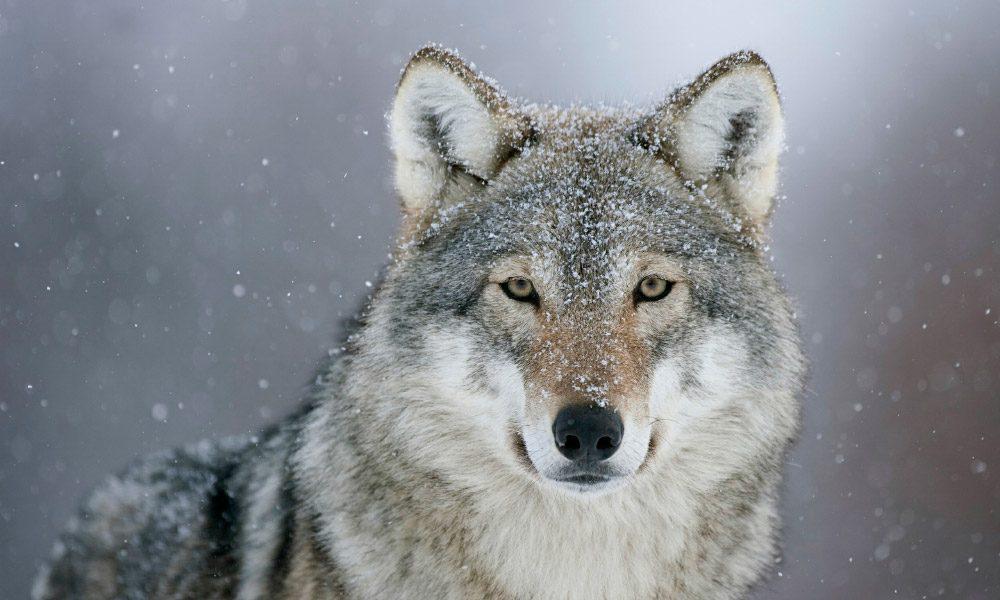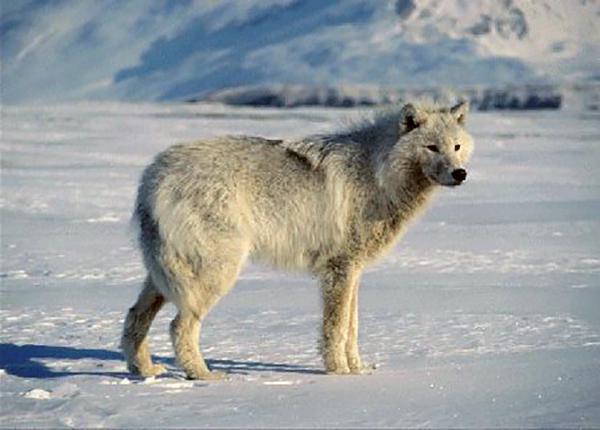The first image is the image on the left, the second image is the image on the right. Assess this claim about the two images: "A dog has its mouth open.". Correct or not? Answer yes or no. No. The first image is the image on the left, the second image is the image on the right. For the images displayed, is the sentence "There is a single white wolf in each of the images." factually correct? Answer yes or no. No. 